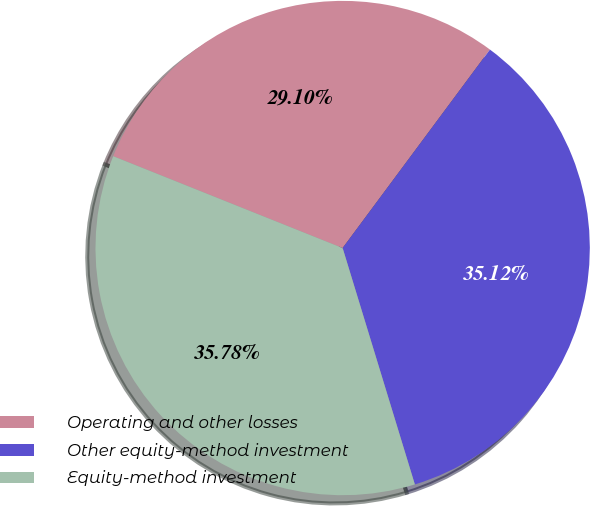Convert chart to OTSL. <chart><loc_0><loc_0><loc_500><loc_500><pie_chart><fcel>Operating and other losses<fcel>Other equity-method investment<fcel>Equity-method investment<nl><fcel>29.1%<fcel>35.12%<fcel>35.78%<nl></chart> 